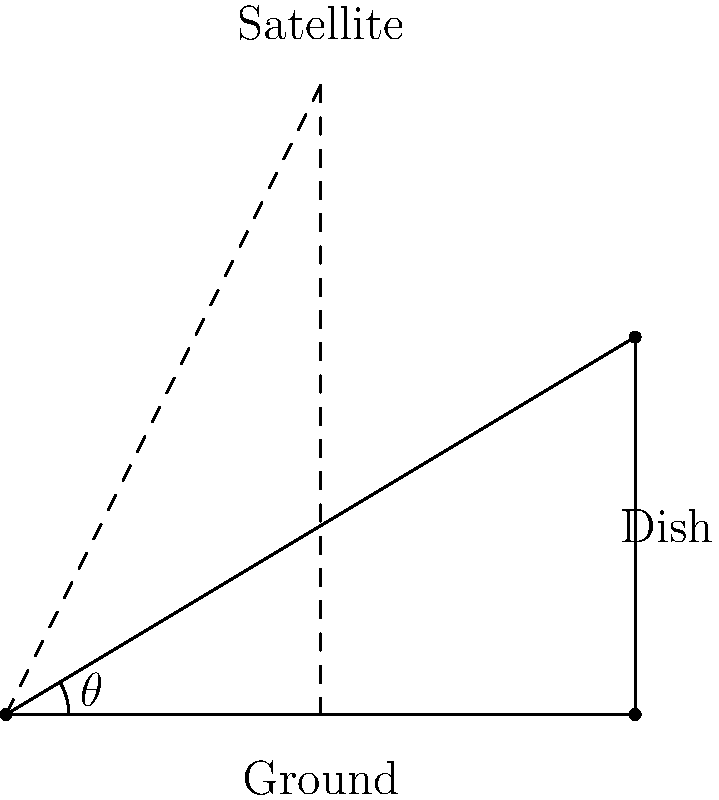A satellite dish needs to be installed for optimal signal reception. The dish is mounted on a building 60 meters tall, and the satellite is directly above a point on the ground 100 meters away from the building. What angle of inclination ($\theta$) should the dish be set at to point directly at the satellite? To solve this problem, we'll use trigonometry:

1) First, we identify the right triangle formed by the building, the ground, and the line of sight to the satellite.

2) In this triangle:
   - The adjacent side (ground distance) is 100 meters
   - The opposite side (building height) is 60 meters
   - The angle we're looking for ($\theta$) is the one between the ground and the line of sight

3) We can use the arctangent function to find this angle:

   $$\theta = \arctan(\frac{\text{opposite}}{\text{adjacent}})$$

4) Plugging in our values:

   $$\theta = \arctan(\frac{60}{100})$$

5) Simplifying:

   $$\theta = \arctan(0.6)$$

6) Using a calculator or computer:

   $$\theta \approx 30.96^\circ$$

Thus, the dish should be inclined at approximately 30.96 degrees from the horizontal to point directly at the satellite.
Answer: $30.96^\circ$ 